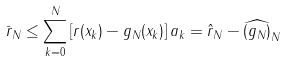Convert formula to latex. <formula><loc_0><loc_0><loc_500><loc_500>\bar { r } _ { N } \leq \sum _ { k = 0 } ^ { N } \left [ r ( x _ { k } ) - g _ { N } ( x _ { k } ) \right ] a _ { k } = \hat { r } _ { N } - \widehat { ( g _ { N } ) } _ { N }</formula> 